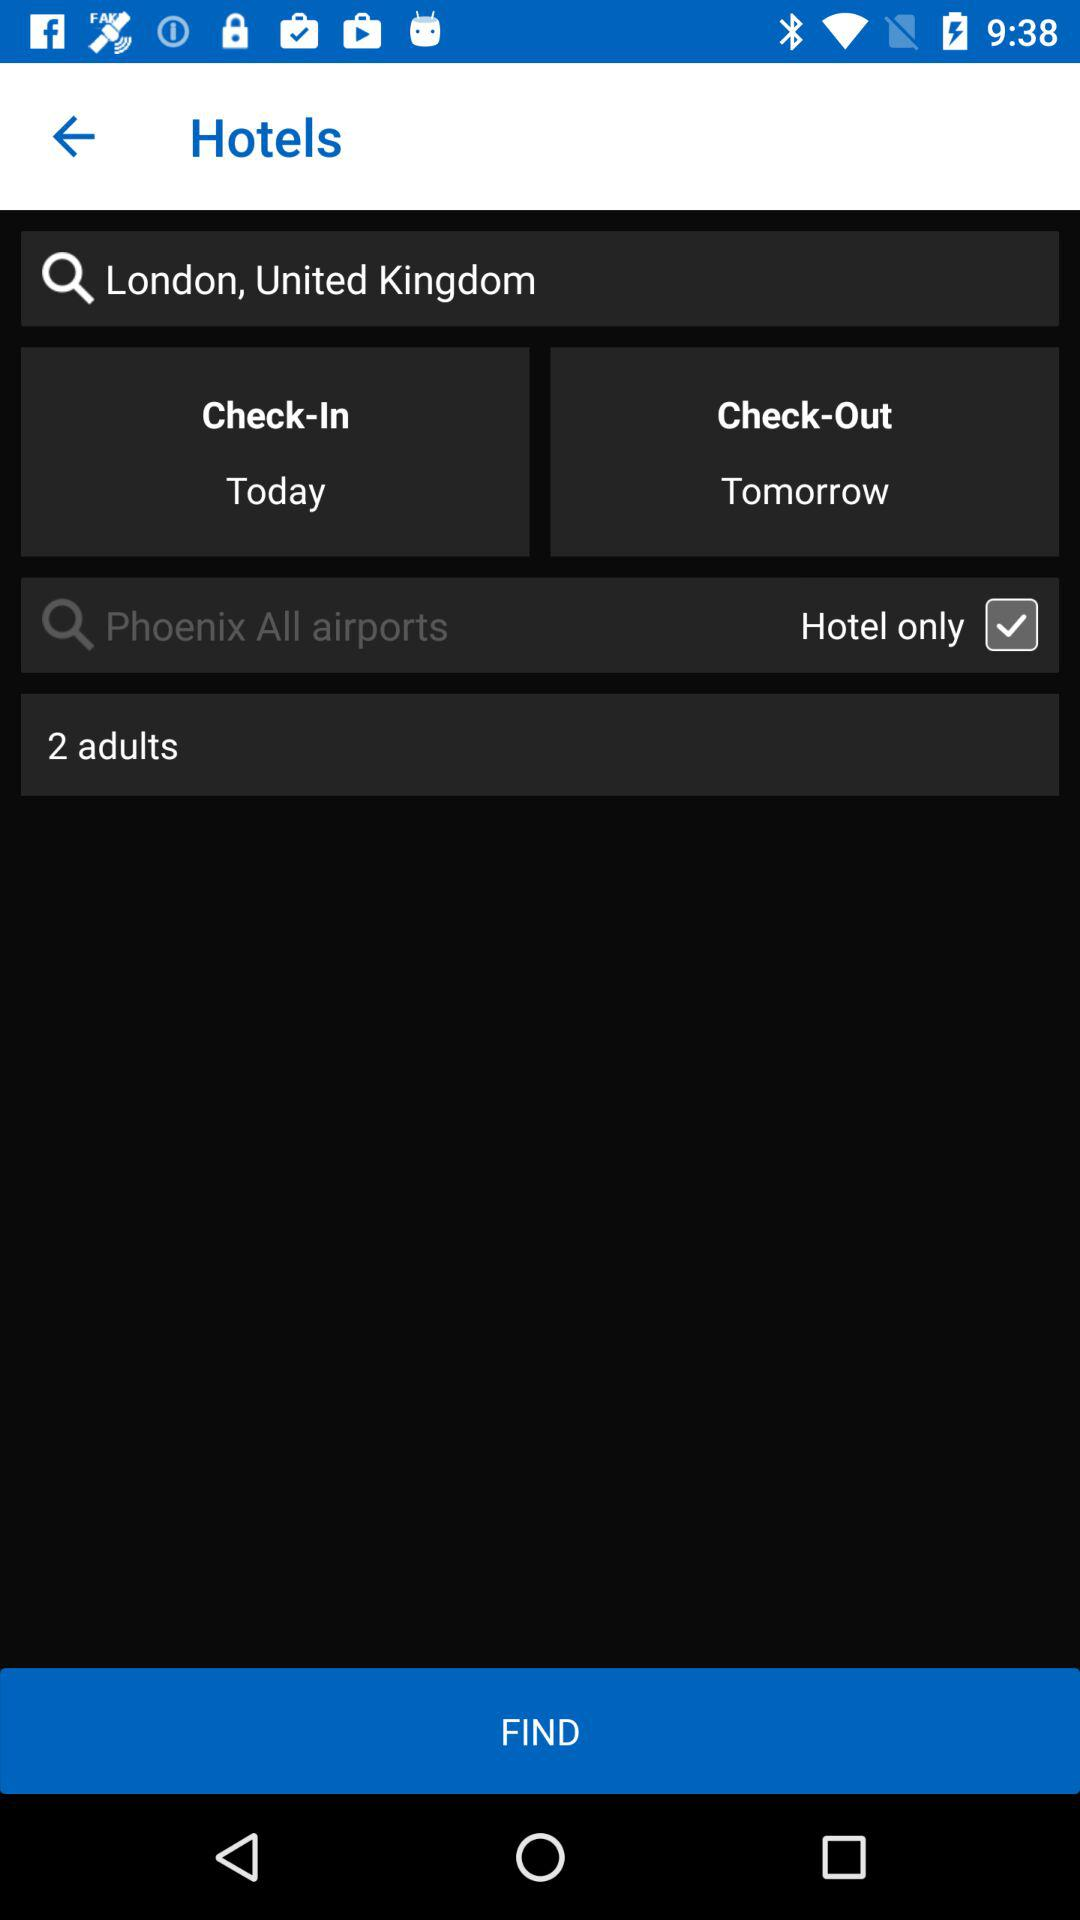How many people are there? There are 2 people. 